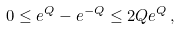<formula> <loc_0><loc_0><loc_500><loc_500>0 \leq e ^ { Q } - e ^ { - Q } \leq 2 Q e ^ { Q } \, ,</formula> 